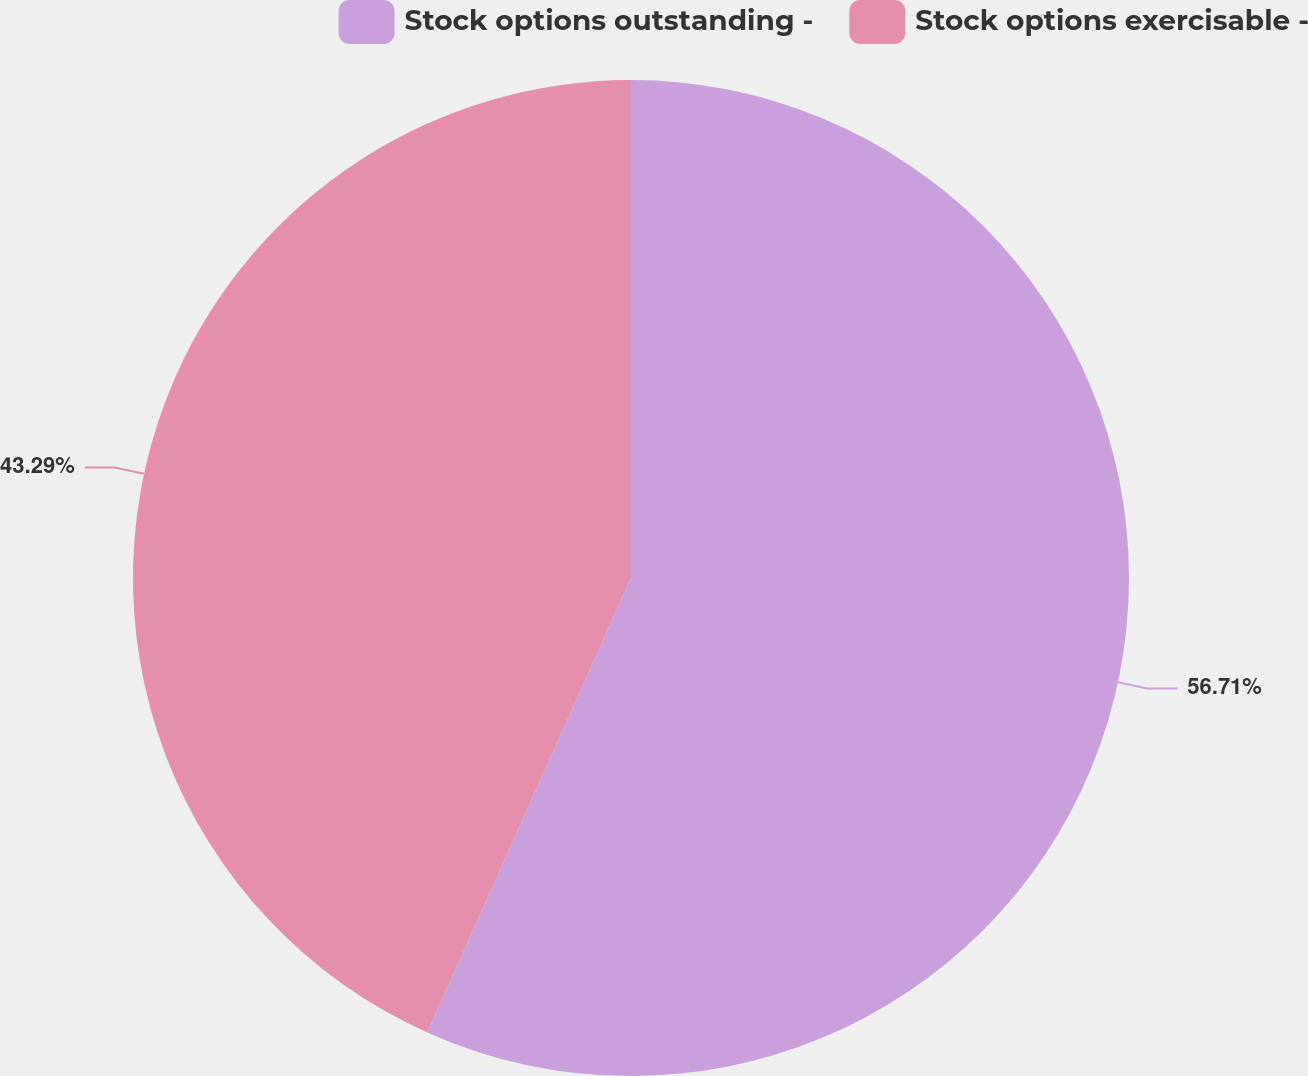<chart> <loc_0><loc_0><loc_500><loc_500><pie_chart><fcel>Stock options outstanding -<fcel>Stock options exercisable -<nl><fcel>56.71%<fcel>43.29%<nl></chart> 